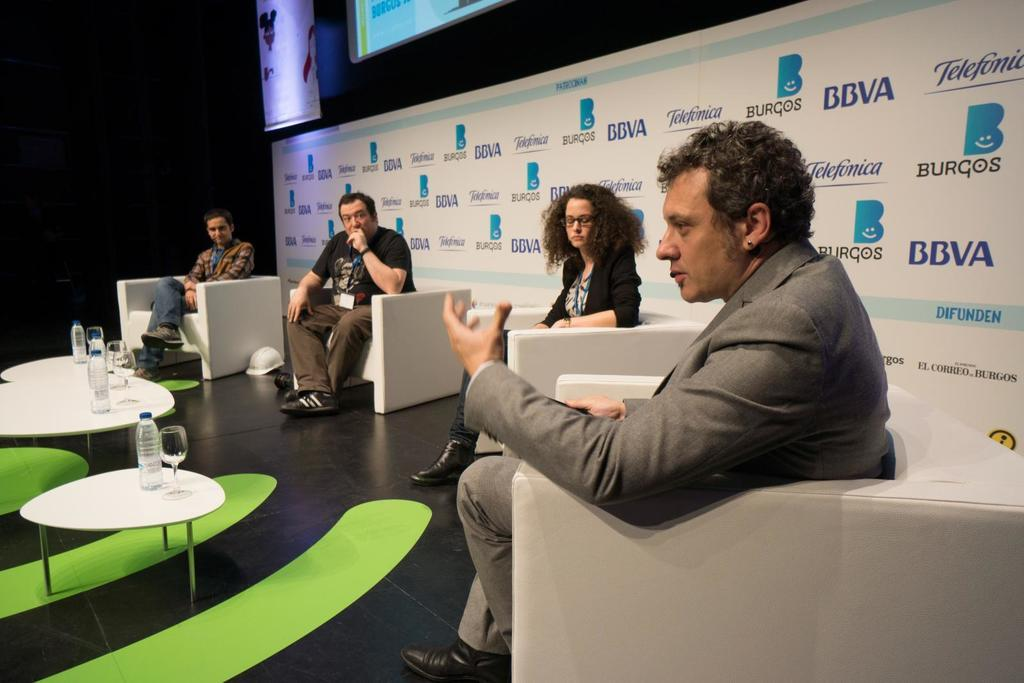What is the main object in the image? There is a screen in the image. What else can be seen in the image besides the screen? There is a banner, people sitting on sofas, tables, glasses, and bottles in the image. How are the people seated in the image? The people are sitting on sofas in the image. What items are on the tables in the image? There are glasses and bottles on the tables in the image. What type of cheese is being served to the nation in the image? There is no cheese or nation mentioned in the image; it features a screen, a banner, people sitting on sofas, tables, glasses, and bottles. 